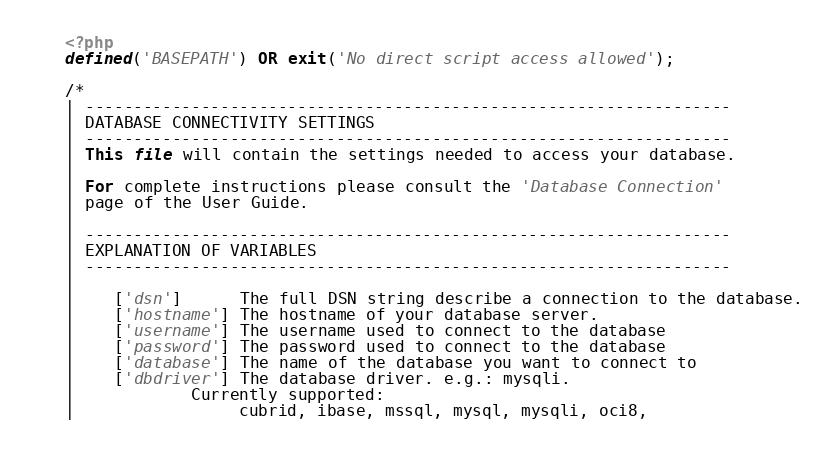<code> <loc_0><loc_0><loc_500><loc_500><_PHP_><?php
defined('BASEPATH') OR exit('No direct script access allowed');

/*
| -------------------------------------------------------------------
| DATABASE CONNECTIVITY SETTINGS
| -------------------------------------------------------------------
| This file will contain the settings needed to access your database.
|
| For complete instructions please consult the 'Database Connection'
| page of the User Guide.
|
| -------------------------------------------------------------------
| EXPLANATION OF VARIABLES
| -------------------------------------------------------------------
|
|	['dsn']      The full DSN string describe a connection to the database.
|	['hostname'] The hostname of your database server.
|	['username'] The username used to connect to the database
|	['password'] The password used to connect to the database
|	['database'] The name of the database you want to connect to
|	['dbdriver'] The database driver. e.g.: mysqli.
|			Currently supported:
|				 cubrid, ibase, mssql, mysql, mysqli, oci8,</code> 